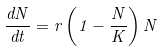Convert formula to latex. <formula><loc_0><loc_0><loc_500><loc_500>\frac { d N } { d t } = r \left ( 1 - \frac { N } { K } \right ) N</formula> 